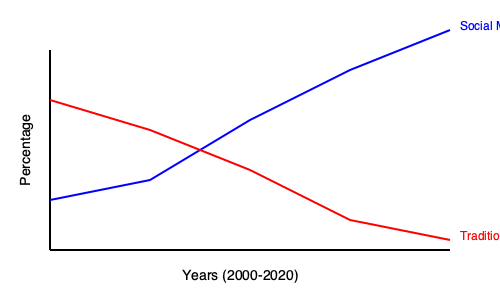Analyze the graph depicting the trends in social media usage and traditional poetry readership from 2000 to 2020. Calculate the rate of change for both trends and discuss how this data might be interpreted by a traditional poet who believes technology dilutes the human essence in poetry. How might this poet argue against the apparent correlation between the rise of social media and the decline of traditional poetry readership? To answer this question, we need to follow these steps:

1. Calculate the rate of change for both trends:
   a. Social Media Usage (blue line):
      Initial value (2000): ~20%
      Final value (2020): ~90%
      Rate of change = $\frac{90\% - 20\%}{20 \text{ years}} = 3.5\%$ per year

   b. Traditional Poetry Readership (red line):
      Initial value (2000): ~80%
      Final value (2020): ~10%
      Rate of change = $\frac{10\% - 80\%}{20 \text{ years}} = -3.5\%$ per year

2. Interpret the data from the perspective of a traditional poet:
   The graph shows an inverse relationship between social media usage and traditional poetry readership. As social media usage increased by 3.5% per year, traditional poetry readership decreased by 3.5% per year.

3. Potential arguments against the apparent correlation:
   a. Correlation does not imply causation: The poet might argue that while the trends appear related, other factors could be responsible for the decline in traditional poetry readership.
   
   b. Quality vs. Quantity: The poet could assert that while readership has declined, the remaining readers might be more deeply engaged with poetry, preserving its essence.
   
   c. Evolution of form: The poet might contend that poetry has adapted to new mediums, and what appears as a decline is actually a transformation of the art form.
   
   d. Cyclical nature of art: The poet could argue that interest in traditional poetry fluctuates over time, and this graph only captures a temporary downturn.
   
   e. Measurement limitations: The poet might question the methodology used to measure "traditional poetry readership," arguing that it fails to capture the true impact and reach of poetry in people's lives.

4. Conclusion:
   A traditional poet believing that technology dilutes the human essence in poetry would likely view this graph as evidence of technology's detrimental effect on poetry appreciation. However, they might also argue that this surface-level correlation oversimplifies the complex relationship between technology and art, failing to capture the enduring power and relevance of traditional poetry in the human experience.
Answer: The data shows an inverse correlation, but a traditional poet might argue that this oversimplifies the complex relationship between technology and poetry, ignoring factors such as the evolution of poetic forms, the cyclical nature of artistic interest, and the limitations of measuring true poetry engagement. 